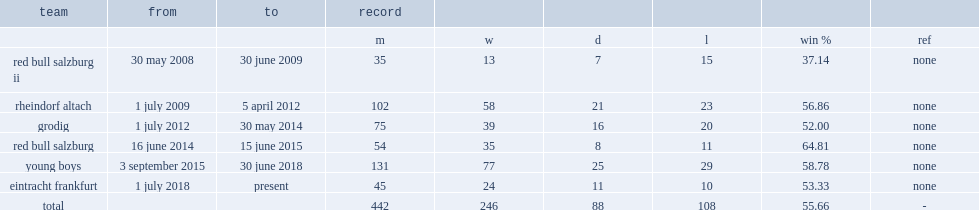Which team did adi hutter teach between 1 july 2009 and 5 april 2012? Rheindorf altach. 